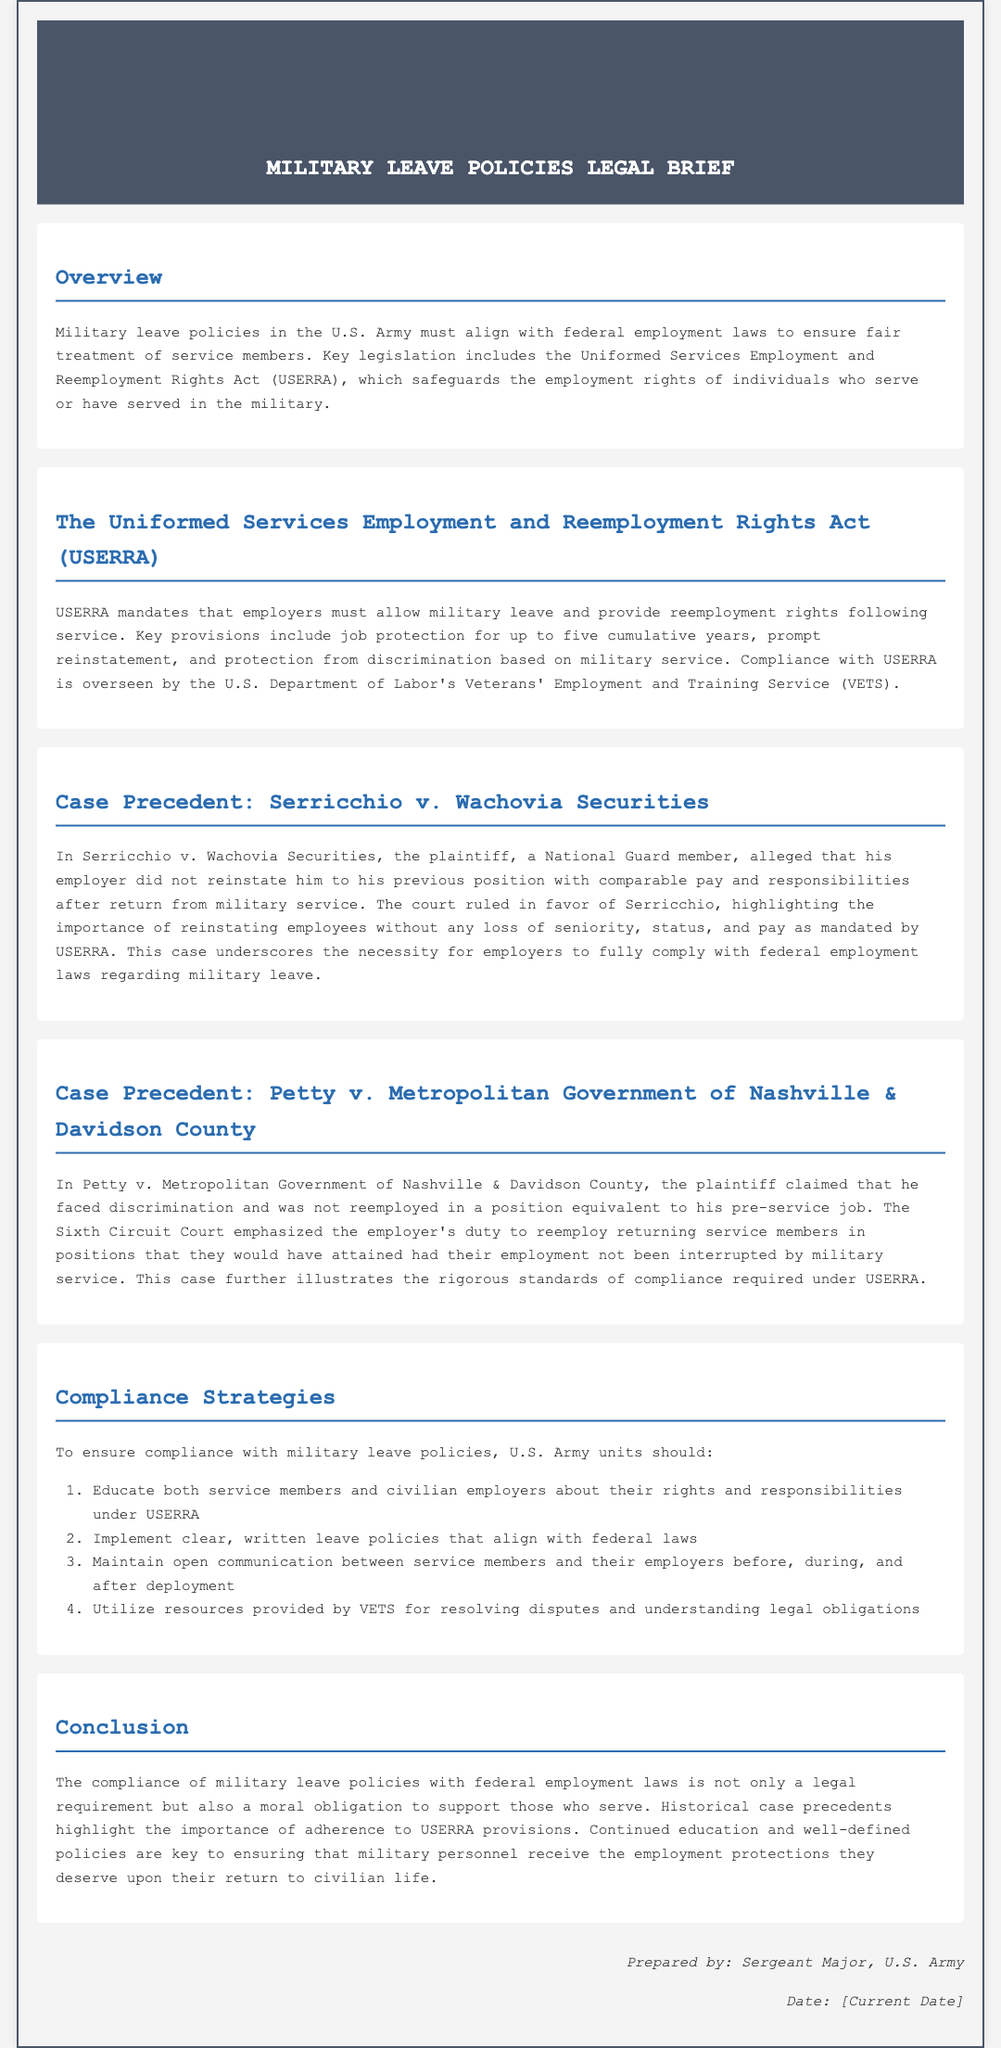What is the title of the document? The title of the document is presented in the header section.
Answer: Military Leave Policies Legal Brief What does USERRA stand for? The abbreviation for USERRA is clarified in the document.
Answer: Uniformed Services Employment and Reemployment Rights Act Who prepared the document? The signature section identifies the individual responsible for the document.
Answer: Sergeant Major, U.S. Army What is the maximum cumulative years for job protection under USERRA? The document specifies the job protection duration provided by USERRA.
Answer: five cumulative years What is a key provision of USERRA? The overview highlights critical provisions of USERRA.
Answer: job protection In which case did a court emphasize the duty to reemploy returning service members? The document mentions specific cases that demonstrate compliance with USERRA.
Answer: Petty v. Metropolitan Government of Nashville & Davidson County What should U.S. Army units implement to ensure compliance? The compliance strategies section provides recommendations for the Army units.
Answer: clear, written leave policies Which department oversees USERRA compliance? The document specifies the overseeing authority for USERRA compliance.
Answer: U.S. Department of Labor's Veterans' Employment and Training Service What is the purpose of educating service members about USERRA? The compliance strategies indicate the importance of education regarding rights under USERRA.
Answer: understanding their rights and responsibilities 